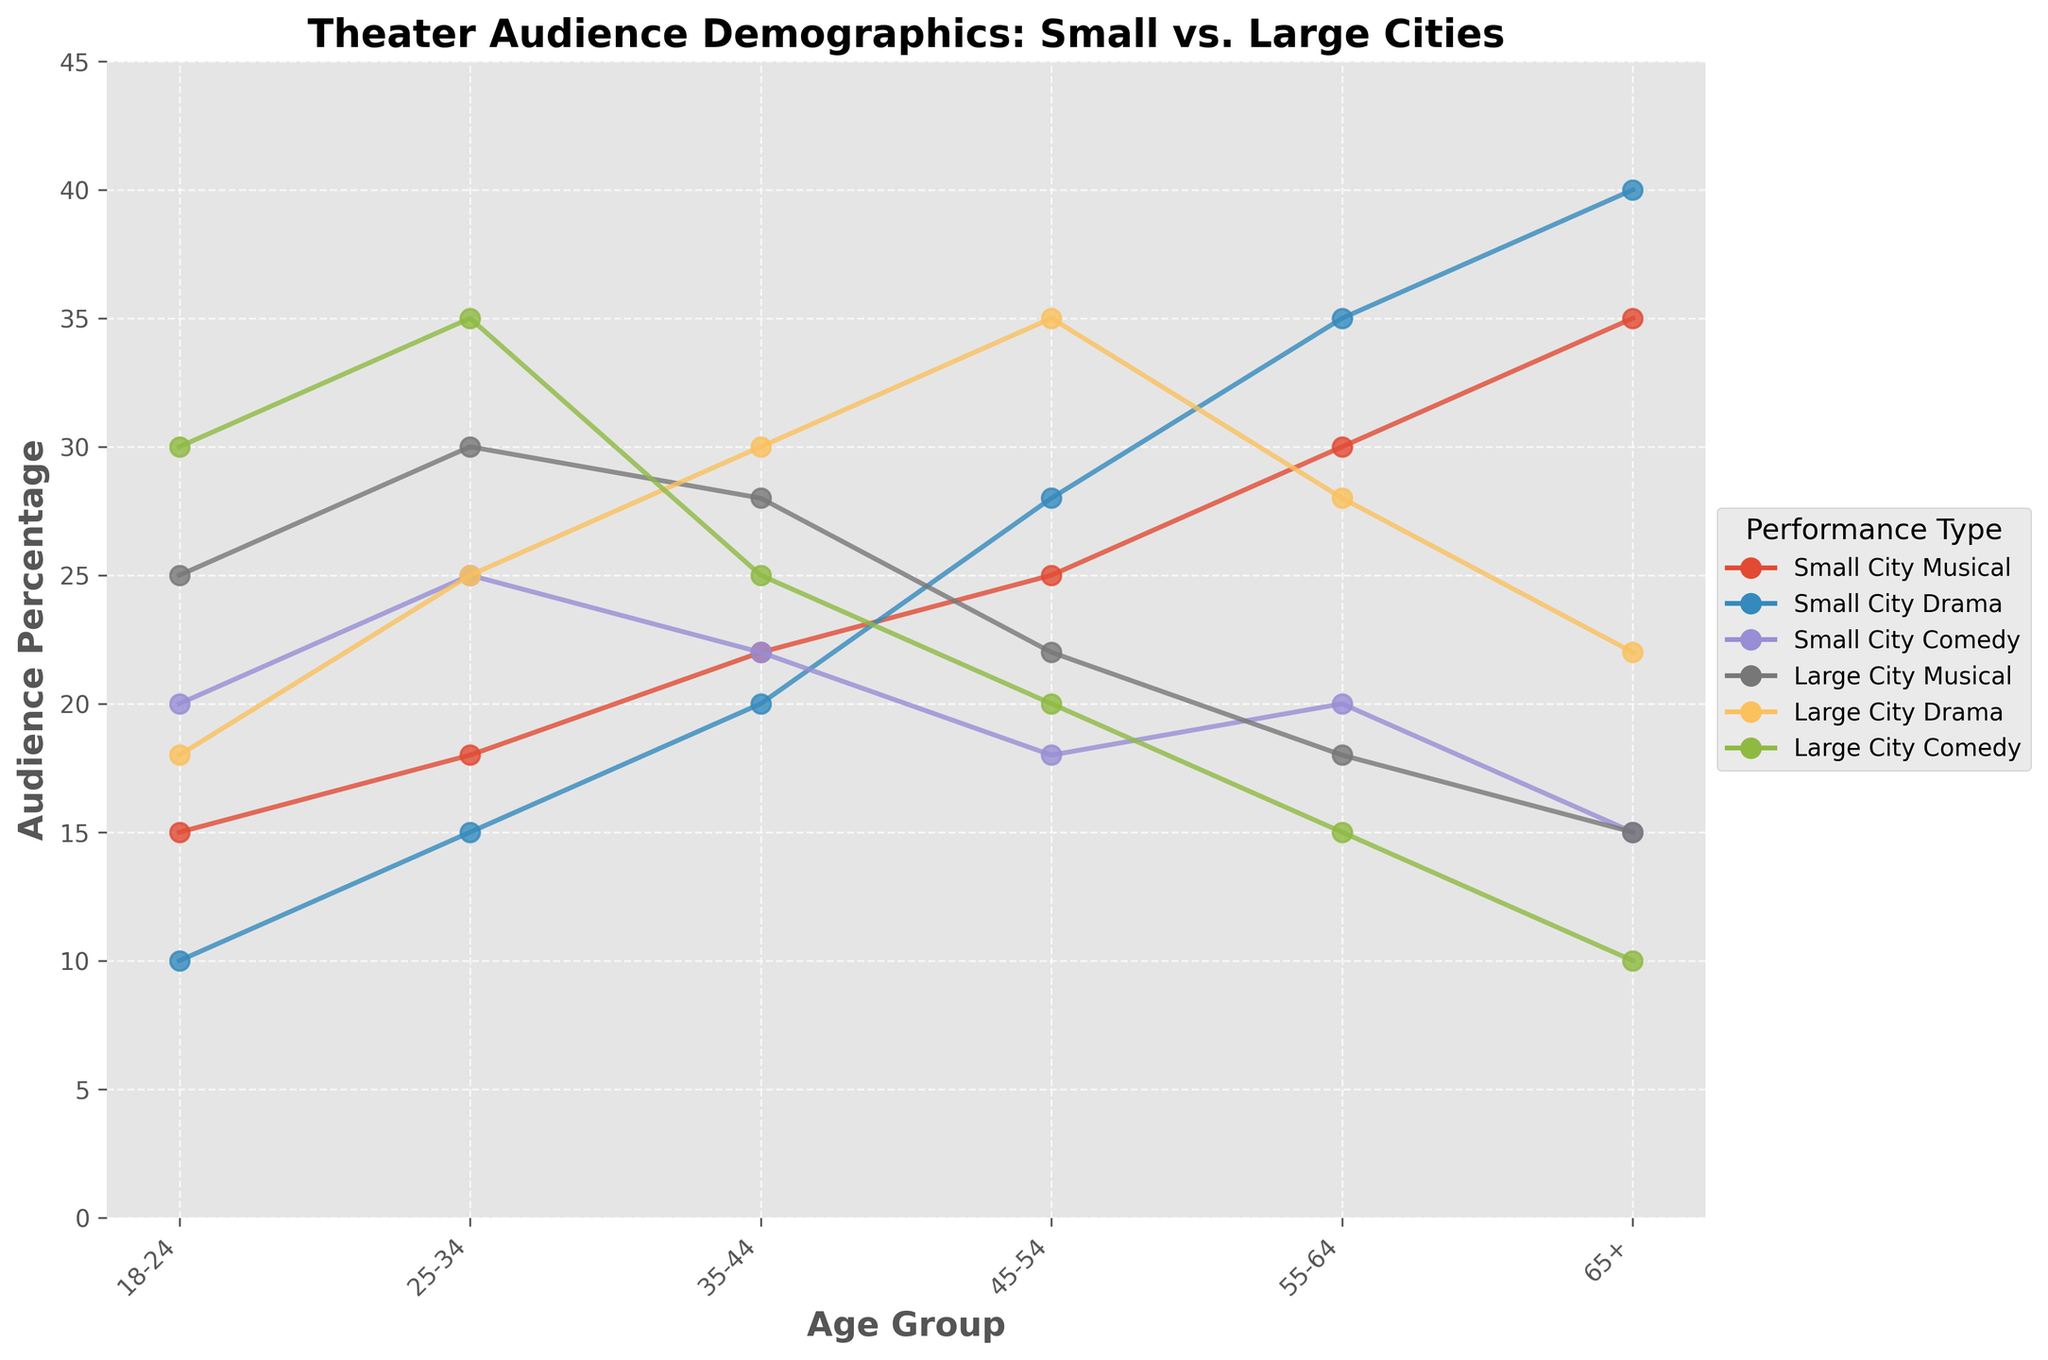What age group is the largest audience for Small City Musicals? By observing the plot lines, we see that for Small City Musicals, the highest point on the graph is at the age group "65+", which means it has the largest audience in that group.
Answer: 65+ Which type of performance attracts the most 18-24 year-olds in large cities? We look at the age group "18-24" and compare the lines for Large City Musical, Large City Drama, and Large City Comedy. The highest line in this age group is the Large City Comedy.
Answer: Large City Comedy What age group shows the biggest difference in audience size between Small City Drama and Large City Drama? We calculate the difference between Small City Drama and Large City Drama for each age group: for 18-24 it is 8, 25-34 it is 10, 35-44 it is 10, 45-54 it is 7, 55-64 it is 7, and for 65+ it is 18. The age group 65+ shows the biggest difference of 18.
Answer: 65+ How does the audience size for Small City Comedy compare to Large City Comedy for the 35-44 age group? By observing the plot lines for 35-44 age group, Small City Comedy has an audience size of 22, and Large City Comedy has 25. Large City Comedy has a larger audience size by 3.
Answer: Large City Comedy is larger by 3 Which performance type has the most consistent audience size across all age groups in small cities? We examine the plot lines for Small City Musical, Small City Drama, and Small City Comedy. Small City Drama's line appears more stable and consistent across the six age groups compared to the others.
Answer: Small City Drama For the 25-34 age group, which type of performance has a larger audience in small cities than in large cities? We examine the plot lines for 25-34 age group. In Small Cities, Small City Musical (18), Small City Drama (15), Small City Comedy (25), and in Large Cities, Large City Musical (30), Large City Drama (25), and Large City Comedy (35). None of the small city audience sizes is larger than large city audience sizes in this age group.
Answer: None What is the average audience size for Large City Drama across all age groups? The values for Large City Drama are 18, 25, 30, 35, 28, 22. Sum of these values is 18 + 25 + 30 + 35 + 28 + 22 = 158. There are 6 age groups, so the average size is 158 / 6 = 26.33
Answer: 26.33 Between Large City Musical and Large City Drama, which performance type shows a higher increase in audience size from the 18-24 to 25-34 age group? The increase for Large City Musical from 18-24 to 25-34 is 30 - 25 = 5, and for Large City Drama it is 25 - 18 = 7. Therefore, Large City Drama shows a higher increase.
Answer: Large City Drama What is the ratio of the audience size of Small City Musicals to Large City Musicals for the 45-54 age group? For the 45-54 age group, Small City Musical has an audience size of 25, and Large City Musical has 22. The ratio is 25 / 22 which simplifies to about 1.14.
Answer: 1.14 